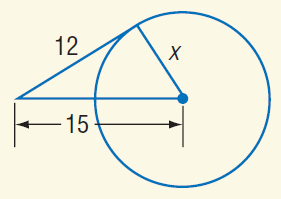Answer the mathemtical geometry problem and directly provide the correct option letter.
Question: Find x. Assume that segments that appear to be tangent are tangent.
Choices: A: 3 B: 9 C: 12 D: 15 B 